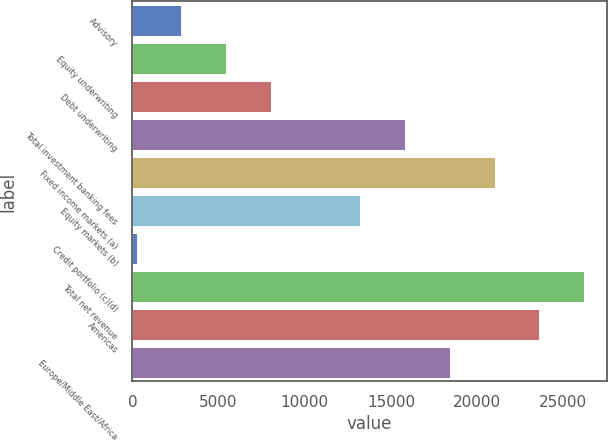<chart> <loc_0><loc_0><loc_500><loc_500><bar_chart><fcel>Advisory<fcel>Equity underwriting<fcel>Debt underwriting<fcel>Total investment banking fees<fcel>Fixed income markets (a)<fcel>Equity markets (b)<fcel>Credit portfolio (c)(d)<fcel>Total net revenue<fcel>Americas<fcel>Europe/Middle East/Africa<nl><fcel>2840.4<fcel>5437.8<fcel>8035.2<fcel>15827.4<fcel>21022.2<fcel>13230<fcel>243<fcel>26217<fcel>23619.6<fcel>18424.8<nl></chart> 